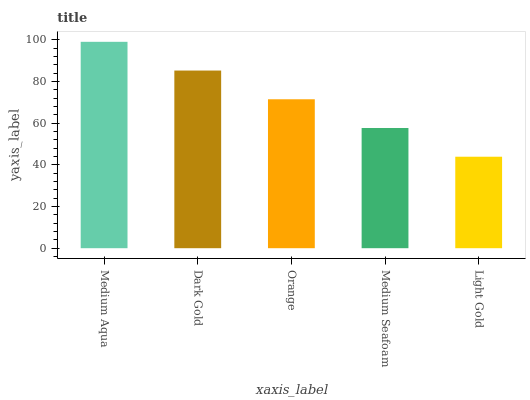Is Light Gold the minimum?
Answer yes or no. Yes. Is Medium Aqua the maximum?
Answer yes or no. Yes. Is Dark Gold the minimum?
Answer yes or no. No. Is Dark Gold the maximum?
Answer yes or no. No. Is Medium Aqua greater than Dark Gold?
Answer yes or no. Yes. Is Dark Gold less than Medium Aqua?
Answer yes or no. Yes. Is Dark Gold greater than Medium Aqua?
Answer yes or no. No. Is Medium Aqua less than Dark Gold?
Answer yes or no. No. Is Orange the high median?
Answer yes or no. Yes. Is Orange the low median?
Answer yes or no. Yes. Is Medium Seafoam the high median?
Answer yes or no. No. Is Light Gold the low median?
Answer yes or no. No. 